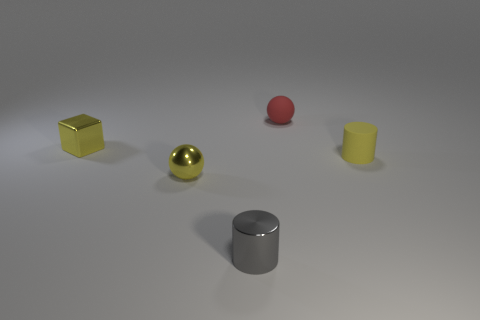Are there more large spheres than tiny gray things?
Keep it short and to the point. No. There is a ball that is behind the ball that is on the left side of the small sphere that is right of the tiny gray thing; what is its size?
Provide a succinct answer. Small. What size is the sphere on the right side of the tiny shiny cylinder?
Offer a very short reply. Small. What number of objects are either tiny metallic objects or small cylinders right of the small metallic cylinder?
Make the answer very short. 4. What number of other things are the same size as the metallic block?
Keep it short and to the point. 4. There is another tiny object that is the same shape as the tiny red matte object; what is its material?
Your response must be concise. Metal. Is the number of tiny gray objects on the left side of the red matte sphere greater than the number of gray cylinders?
Ensure brevity in your answer.  No. Are there any other things that have the same color as the tiny block?
Give a very brief answer. Yes. There is a tiny gray object that is made of the same material as the yellow sphere; what is its shape?
Provide a succinct answer. Cylinder. Are the small object that is behind the small yellow metallic cube and the small block made of the same material?
Your answer should be very brief. No. 